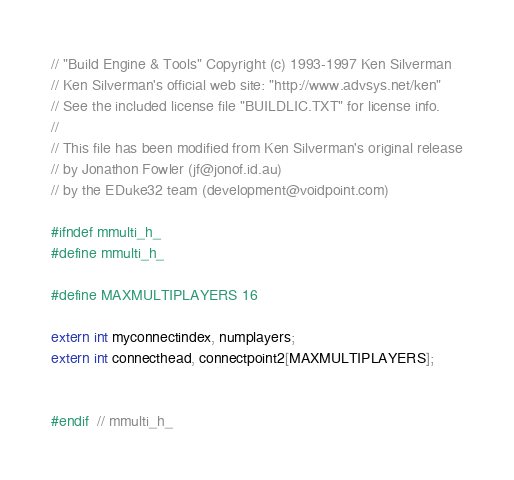<code> <loc_0><loc_0><loc_500><loc_500><_C_>// "Build Engine & Tools" Copyright (c) 1993-1997 Ken Silverman
// Ken Silverman's official web site: "http://www.advsys.net/ken"
// See the included license file "BUILDLIC.TXT" for license info.
//
// This file has been modified from Ken Silverman's original release
// by Jonathon Fowler (jf@jonof.id.au)
// by the EDuke32 team (development@voidpoint.com)

#ifndef mmulti_h_
#define mmulti_h_

#define MAXMULTIPLAYERS 16

extern int myconnectindex, numplayers;
extern int connecthead, connectpoint2[MAXMULTIPLAYERS];


#endif  // mmulti_h_

</code> 